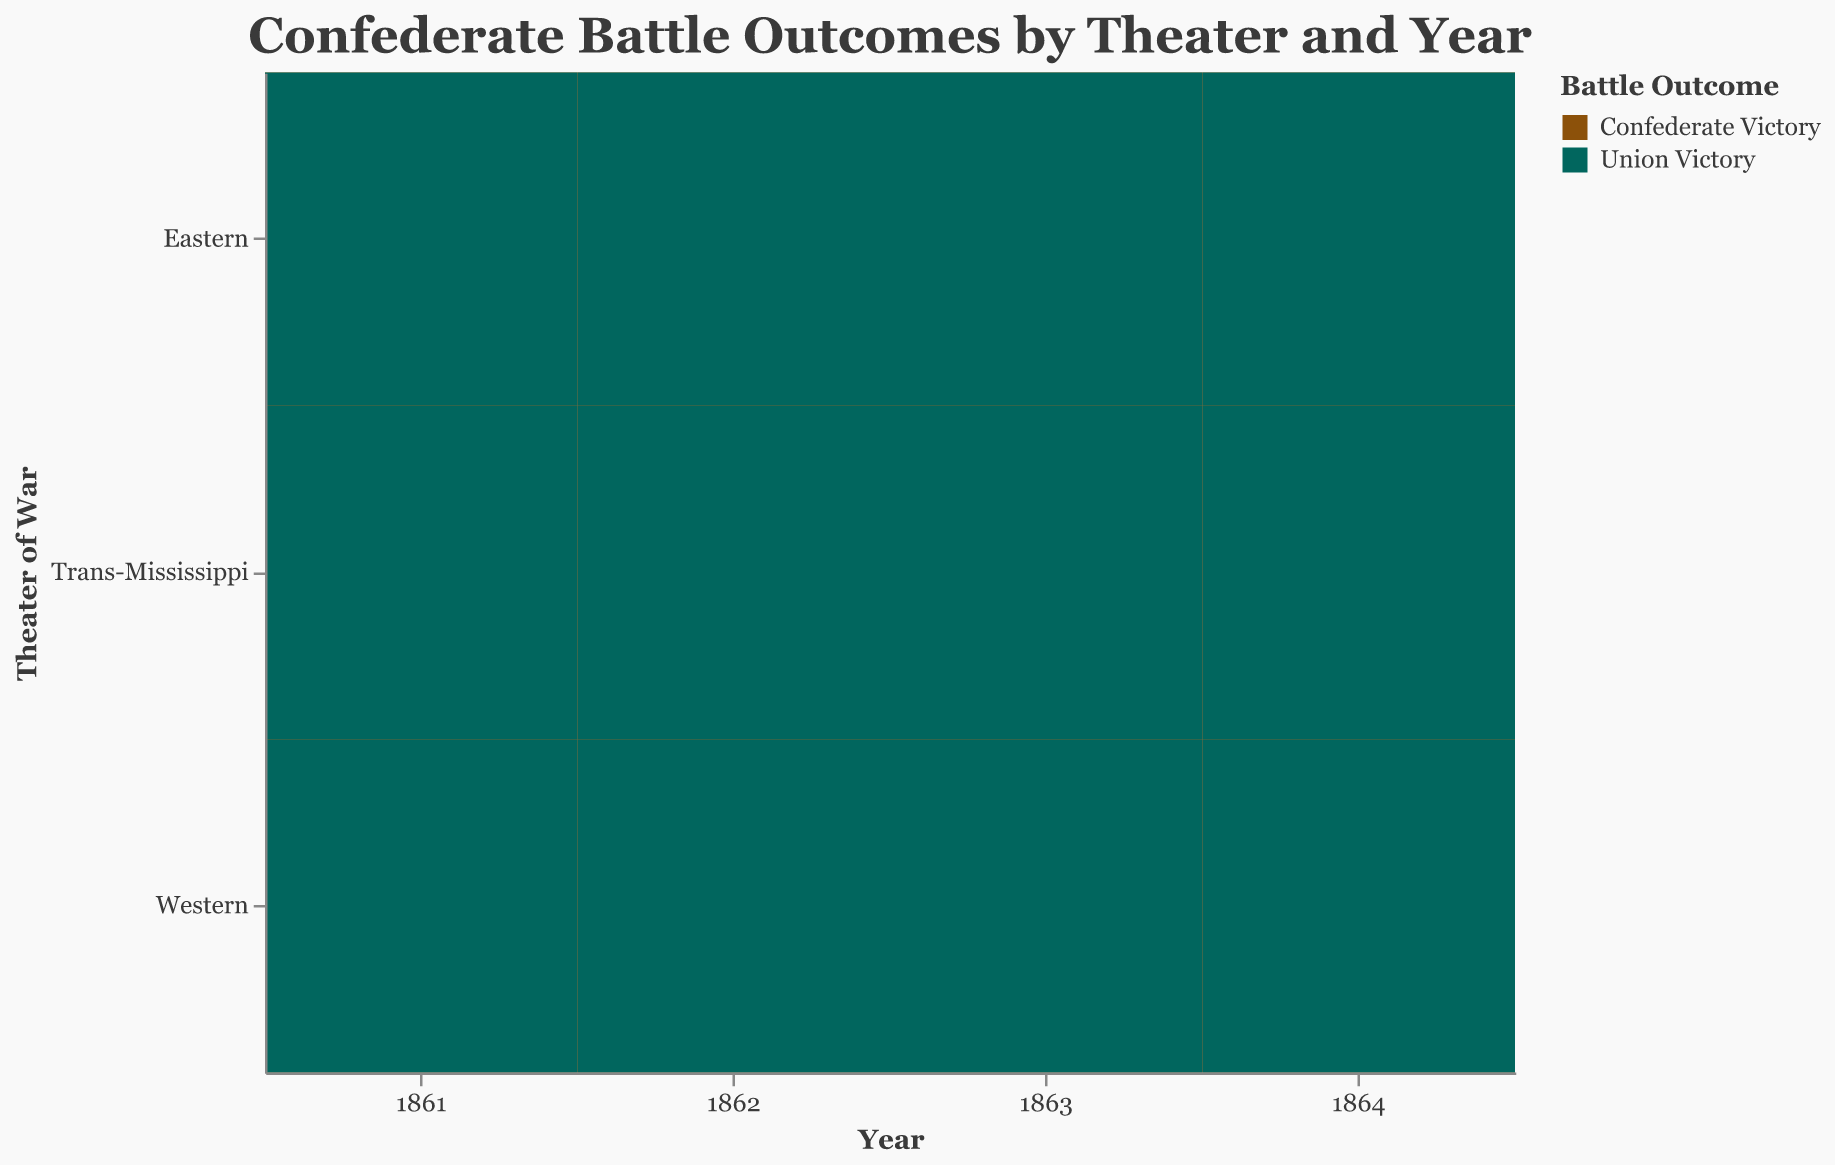What's the title of the figure? The title is located at the top and center of the figure. It reads "Confederate Battle Outcomes by Theater and Year."
Answer: Confederate Battle Outcomes by Theater and Year Which year had the most Confederate victories? To find this, look at the blocks representing "Confederate Victory" across all years and sum the counts for each year. The year with the highest total is 1862 (7 in the Eastern theater, 4 in the Western theater, and 3 in the Trans-Mississippi theater).
Answer: 1862 In which theater did Confederate forces have fewer victories as the years progressed? Observing the size of the "Confederate Victory" blocks for each theater over the years, notice that in the Eastern theater, the count decreases from 5 (in 1861) to 2 (in 1864).
Answer: Eastern Which year and theater combination had the highest number of Union victories? Locate the largest block of "Union Victory" by size. This occurs in the Eastern theater in 1864 with a count of 8.
Answer: Eastern, 1864 How do Confederate victories in 1864 compare across theaters? Look at the "Confederate Victory" blocks for 1864 in each theater. Counts are 2 (Eastern), 1 (Western), and 1 (Trans-Mississippi). The largest count is in the Eastern theater.
Answer: Eastern had the most, Western and Trans-Mississippi had equal counts How many Confederate victories happened in the Eastern theater from 1861 to 1864 combined? Sum up the counts of "Confederate Victory" in the Eastern theater for all years: 5 (1861) + 7 (1862) + 3 (1863) + 2 (1864) = 17.
Answer: 17 Did Union victories increase or decrease over time in the Western theater? Observing the "Union Victory" blocks in the Western theater, the counts increase steadily from 2 (1861) to 9 (1864).
Answer: Increase Which theater had the most consistent number of Confederate victories each year? Analyzing the "Confederate Victory" blocks across theaters each year, the Trans-Mississippi theater shows the least variation with counts of 2, 3, 2, and 1.
Answer: Trans-Mississippi Which outcome (Confederate or Union victory) was more frequent in the Western theater by 1864? Look at the counts in the Western theater for 1864. There is 1 Confederate victory and 9 Union victories. Union victories are more frequent.
Answer: Union victory How did Union victories in the Trans-Mississippi theater in 1862 compare to those in the Eastern theater in 1862? The figure shows Union victories in the Trans-Mississippi theater in 1862 with a count of 2 and in the Eastern theater in 1862 with a count of 4.
Answer: Eastern theater had more Union victories 